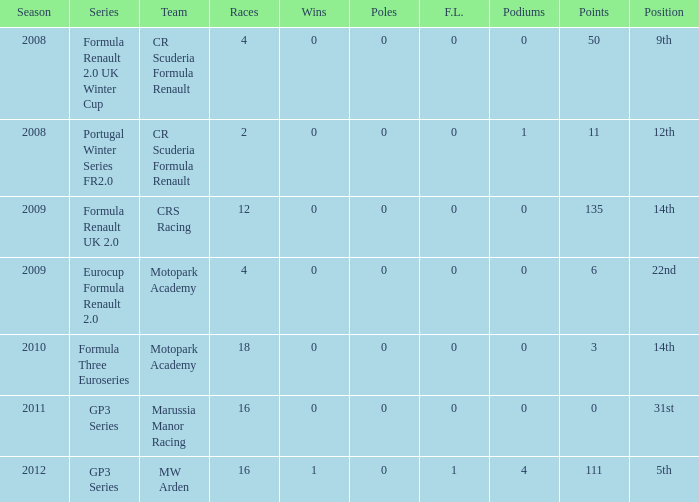What is the least amount of podiums? 0.0. 